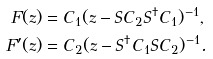<formula> <loc_0><loc_0><loc_500><loc_500>F ( z ) & = C _ { 1 } ( z - S C _ { 2 } S ^ { \dagger } C _ { 1 } ) ^ { - 1 } , \\ F ^ { \prime } ( z ) & = C _ { 2 } ( z - S ^ { \dagger } C _ { 1 } S C _ { 2 } ) ^ { - 1 } .</formula> 